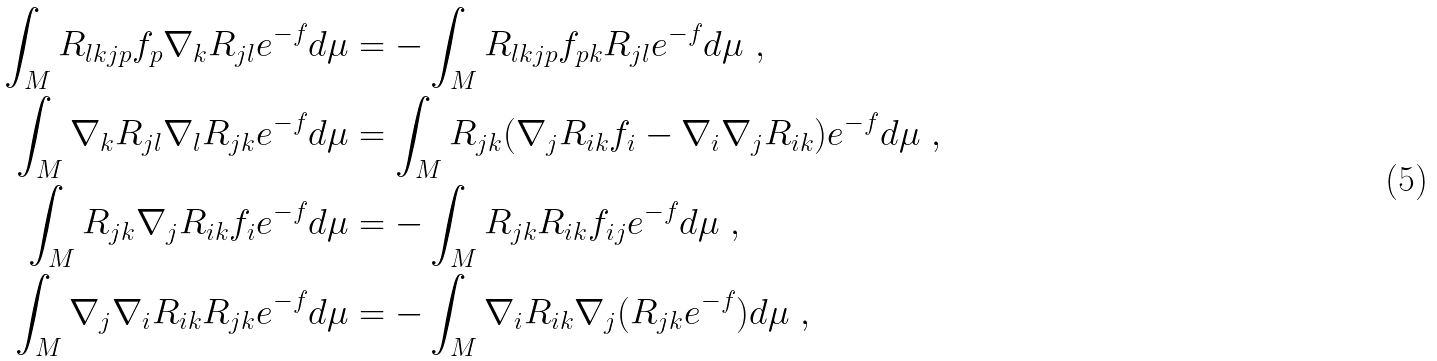<formula> <loc_0><loc_0><loc_500><loc_500>\int _ { M } R _ { l k j p } f _ { p } \nabla _ { k } R _ { j l } e ^ { - f } d \mu & = - \int _ { M } R _ { l k j p } f _ { p k } R _ { j l } e ^ { - f } d \mu \ , \\ \int _ { M } \nabla _ { k } R _ { j l } \nabla _ { l } R _ { j k } e ^ { - f } d \mu & = \int _ { M } R _ { j k } ( \nabla _ { j } R _ { i k } f _ { i } - \nabla _ { i } \nabla _ { j } R _ { i k } ) e ^ { - f } d \mu \ , \\ \int _ { M } R _ { j k } \nabla _ { j } R _ { i k } f _ { i } e ^ { - f } d \mu & = - \int _ { M } R _ { j k } R _ { i k } f _ { i j } e ^ { - f } d \mu \ , \\ \int _ { M } \nabla _ { j } \nabla _ { i } R _ { i k } R _ { j k } e ^ { - f } d \mu & = - \int _ { M } \nabla _ { i } R _ { i k } \nabla _ { j } ( R _ { j k } e ^ { - f } ) d \mu \ ,</formula> 